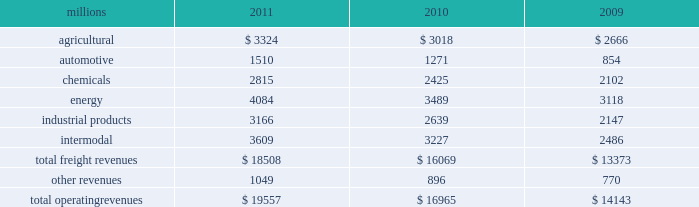Notes to the consolidated financial statements union pacific corporation and subsidiary companies for purposes of this report , unless the context otherwise requires , all references herein to the 201ccorporation 201d , 201cupc 201d , 201cwe 201d , 201cus 201d , and 201cour 201d mean union pacific corporation and its subsidiaries , including union pacific railroad company , which will be separately referred to herein as 201cuprr 201d or the 201crailroad 201d .
Nature of operations operations and segmentation 2013 we are a class i railroad that operates in the u.s .
Our network includes 31898 route miles , linking pacific coast and gulf coast ports with the midwest and eastern u.s .
Gateways and providing several corridors to key mexican gateways .
We own 26027 miles and operate on the remainder pursuant to trackage rights or leases .
We serve the western two-thirds of the country and maintain coordinated schedules with other rail carriers for the handling of freight to and from the atlantic coast , the pacific coast , the southeast , the southwest , canada , and mexico .
Export and import traffic is moved through gulf coast and pacific coast ports and across the mexican and canadian borders .
The railroad , along with its subsidiaries and rail affiliates , is our one reportable operating segment .
Although revenue is analyzed by commodity group , we analyze the net financial results of the railroad as one segment due to the integrated nature of our rail network .
The table provides freight revenue by commodity group : millions 2011 2010 2009 .
Although our revenues are principally derived from customers domiciled in the u.s. , the ultimate points of origination or destination for some products transported by us are outside the u.s .
Basis of presentation 2013 the consolidated financial statements are presented in accordance with accounting principles generally accepted in the u.s .
( gaap ) as codified in the financial accounting standards board ( fasb ) accounting standards codification ( asc ) .
Certain prior year amounts have been disaggregated to provide more detail and conform to the current period financial statement presentation .
Significant accounting policies principles of consolidation 2013 the consolidated financial statements include the accounts of union pacific corporation and all of its subsidiaries .
Investments in affiliated companies ( 20% ( 20 % ) to 50% ( 50 % ) owned ) are accounted for using the equity method of accounting .
All intercompany transactions are eliminated .
We currently have no less than majority-owned investments that require consolidation under variable interest entity requirements .
Cash and cash equivalents 2013 cash equivalents consist of investments with original maturities of three months or less .
Accounts receivable 2013 accounts receivable includes receivables reduced by an allowance for doubtful accounts .
The allowance is based upon historical losses , credit worthiness of customers , and current economic conditions .
Receivables not expected to be collected in one year and the associated allowances are classified as other assets in our consolidated statements of financial position. .
Using a three year average , the industrial products was what percent of total revenue? 
Computations: divide(table_sum(industrial products, none), table_sum(total freight revenues, none))
Answer: 0.16584. 